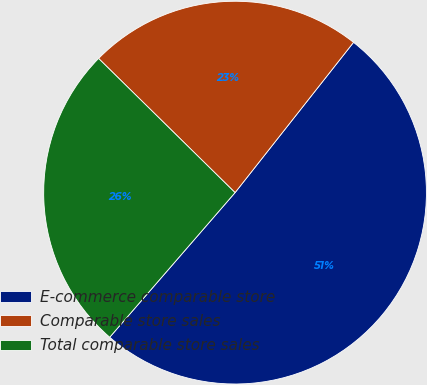Convert chart. <chart><loc_0><loc_0><loc_500><loc_500><pie_chart><fcel>E-commerce comparable store<fcel>Comparable store sales<fcel>Total comparable store sales<nl><fcel>50.74%<fcel>23.26%<fcel>26.0%<nl></chart> 